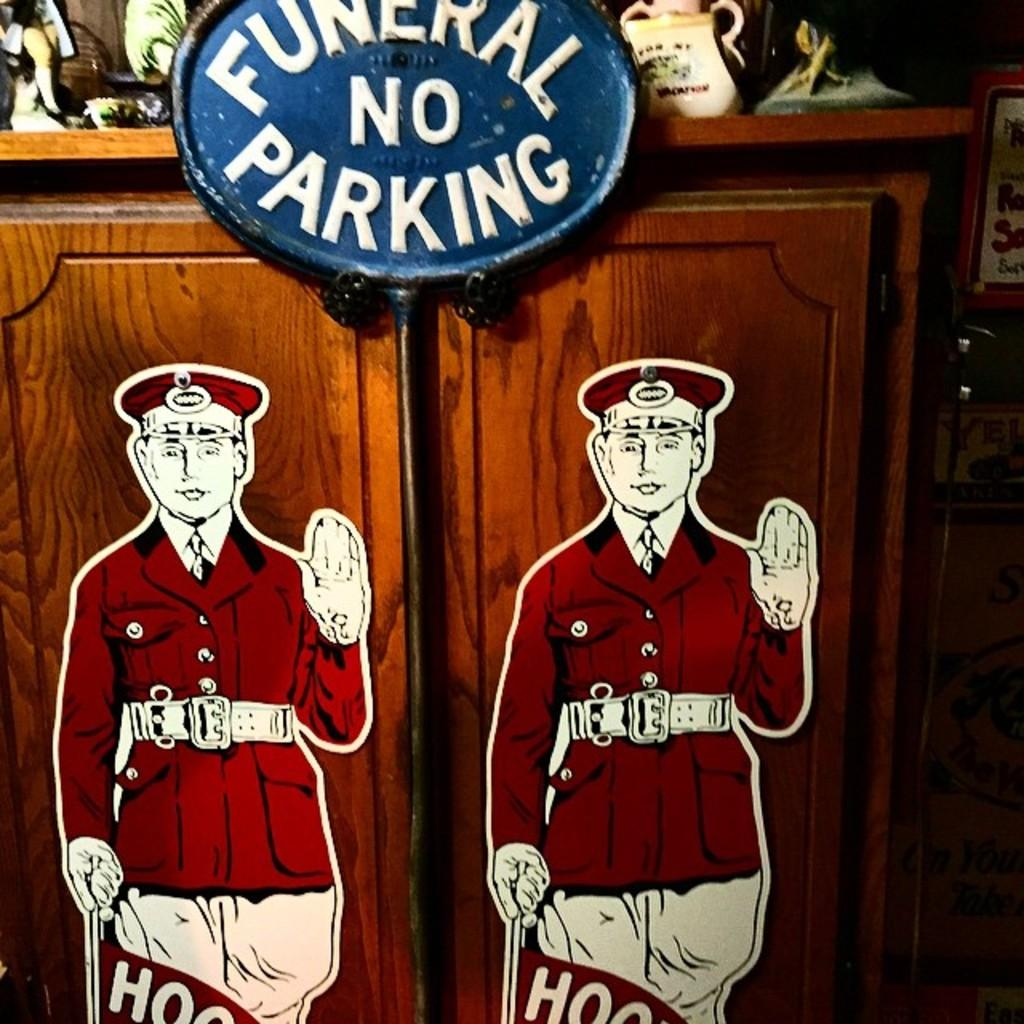What type of decoration is on the cupboard doors in the image? There are stickers of a person on the cupboard doors. What can be seen in the middle of the image? There is a pole in the image. What is located at the top of the image? There are objects on a cupboard table at the top of the image. What is on the right side of the image? There are objects on the right side of the image. What type of prose is written on the pole in the image? There is no prose or writing present on the pole in the image. How does the selection of objects on the right side of the image contribute to the overall debt of the household? There is no information about debt or the household's financial situation in the image, so it cannot be determined how the objects contribute to the overall debt. 